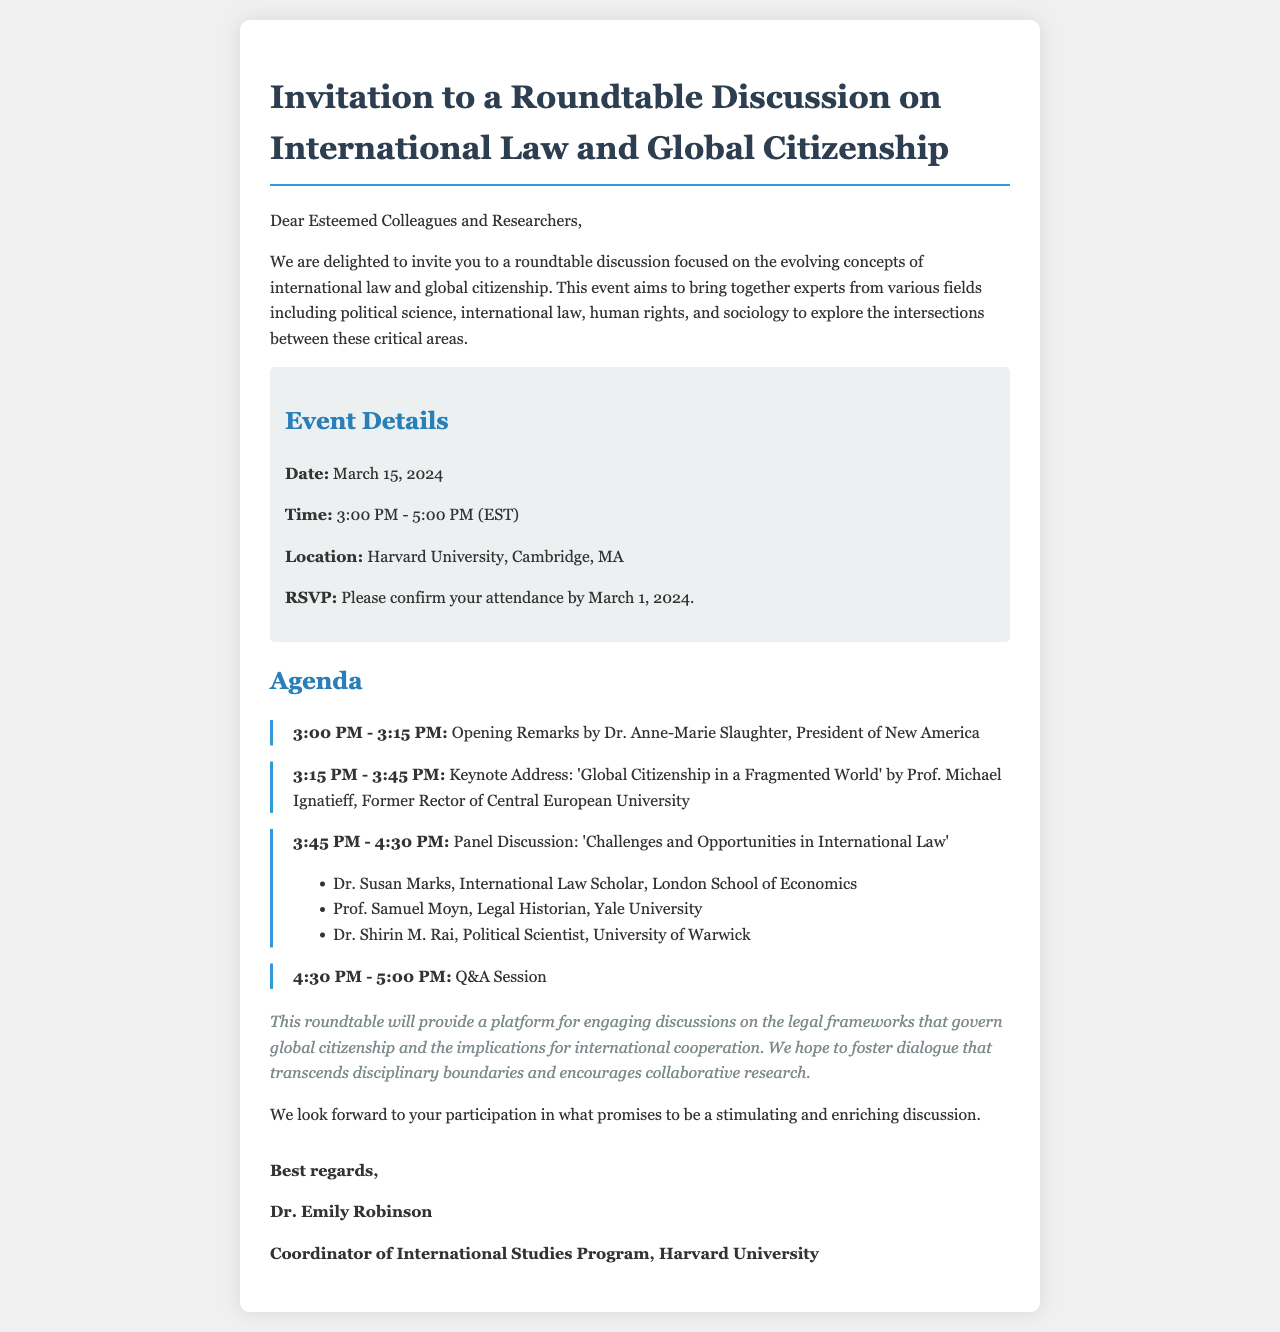What is the date of the event? The document specifies that the event will take place on March 15, 2024.
Answer: March 15, 2024 Who is delivering the keynote address? The keynote address is given by Prof. Michael Ignatieff, according to the agenda section.
Answer: Prof. Michael Ignatieff What time does the discussion start? The event details indicate that the roundtable discussion will start at 3:00 PM.
Answer: 3:00 PM Where is the location of the roundtable? The location of the event is mentioned as Harvard University, Cambridge, MA.
Answer: Harvard University, Cambridge, MA What is the RSVP deadline? The invitation states that attendees should confirm their attendance by March 1, 2024.
Answer: March 1, 2024 What is the purpose of the roundtable? The document outlines that the purpose is to engage in discussions on legal frameworks governing global citizenship.
Answer: Engaging discussions on legal frameworks Who is the coordinator of the event? The signature section identifies Dr. Emily Robinson as the coordinator of the event.
Answer: Dr. Emily Robinson What topic is being addressed in the panel discussion? The agenda mentions the topic of the panel discussion as 'Challenges and Opportunities in International Law'.
Answer: Challenges and Opportunities in International Law How long is the Q&A session scheduled for? The agenda reveals that the Q&A session is scheduled for 30 minutes.
Answer: 30 minutes 